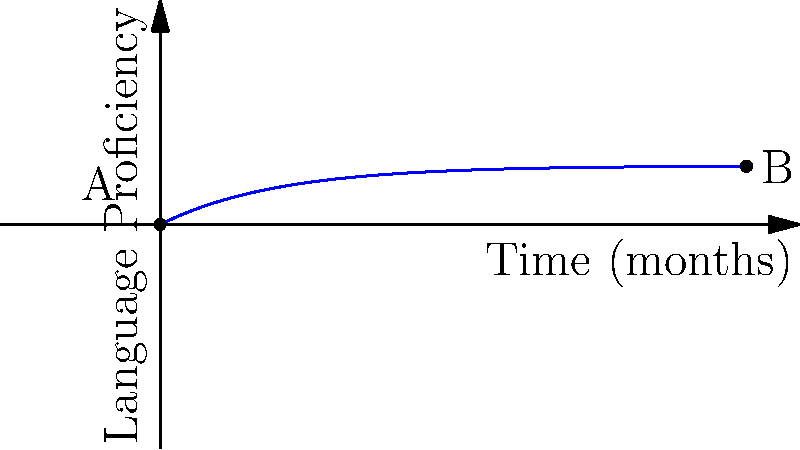Consider the topological manifold representing language acquisition progress over time, as shown in the graph. If the curve from point A to point B is homeomorphic to a line segment, what does this imply about the continuity of the language learning process? To answer this question, let's break it down step-by-step:

1. Topological manifold: The graph represents language acquisition progress as a smooth curve on a 2D plane, which can be considered a topological manifold.

2. Homeomorphism: A homeomorphism is a continuous function with a continuous inverse, preserving topological properties.

3. Line segment: A line segment is a simple, connected, and continuous object in topology.

4. Curve A to B: The curve from A to B represents the language learning progress over time.

5. Homeomorphic to a line segment: If the curve is homeomorphic to a line segment, it means:
   a) There's a continuous, one-to-one mapping between the curve and a line segment.
   b) The curve has no breaks, jumps, or self-intersections.

6. Implications for language learning:
   a) Continuity: The learning process is continuous, with no abrupt jumps or reversals.
   b) Monotonicity: Progress consistently moves forward, never backward.
   c) Smoothness: Changes in proficiency are gradual and without sudden spikes.

7. Cognitive perspective: This aligns with the concept of brain plasticity, suggesting that language acquisition occurs through consistent, incremental changes in neural connections.

Therefore, the homeomorphism between the curve and a line segment implies that the language learning process is continuous, progressive, and smooth, reflecting the gradual nature of neural plasticity in language acquisition.
Answer: Continuous, progressive, and smooth language learning process 